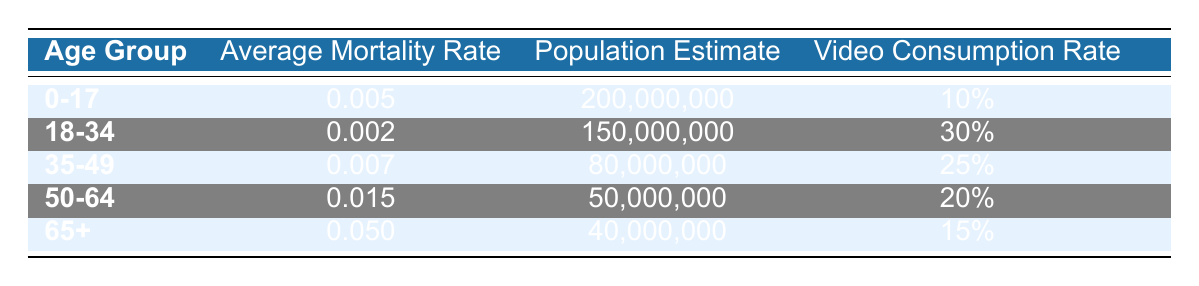What is the Average Mortality Rate for the age group 18-34? The Average Mortality Rate for the age group 18-34 is given directly in the table as 0.002.
Answer: 0.002 What is the total Population Estimate for the age groups 35-49 and 50-64 combined? The Population Estimate for age group 35-49 is 80,000,000, and for 50-64 it is 50,000,000. Adding these two estimates gives 80,000,000 + 50,000,000 = 130,000,000.
Answer: 130,000,000 Is the Video Consumption Rate for the age group 65+ greater than 20%? The Video Consumption Rate for the age group 65+ is 15%, which is less than 20%. Therefore, the statement is false.
Answer: No Which age group has the highest Average Mortality Rate, and what is that rate? By checking all the Average Mortality Rates listed, the age group 65+ has the highest rate at 0.050.
Answer: 65+; 0.050 What is the average Video Consumption Rate of all age groups? The consumption rates are 10%, 30%, 25%, 20%, and 15%. To find the average: (10 + 30 + 25 + 20 + 15) / 5 = 100 / 5 = 20%.
Answer: 20% What is the difference in Average Mortality Rates between the age groups 0-17 and 50-64? The Average Mortality Rate for 0-17 is 0.005, and for 50-64 is 0.015. The difference is 0.015 - 0.005 = 0.010.
Answer: 0.010 Is the Population Estimate for the age group 0-17 less than that of the age group 65+? The Population Estimate for 0-17 is 200,000,000, while for 65+ it is 40,000,000. Since 200,000,000 is greater than 40,000,000, this statement is false.
Answer: No What percent of the total estimated population do video consumers aged 18-34 represent? The total population estimate across all age groups is 200,000,000 + 150,000,000 + 80,000,000 + 50,000,000 + 40,000,000 = 520,000,000. The population for 18-34 is 150,000,000. The percentage is (150,000,000 / 520,000,000) * 100 = approximately 28.85%.
Answer: 28.85% 